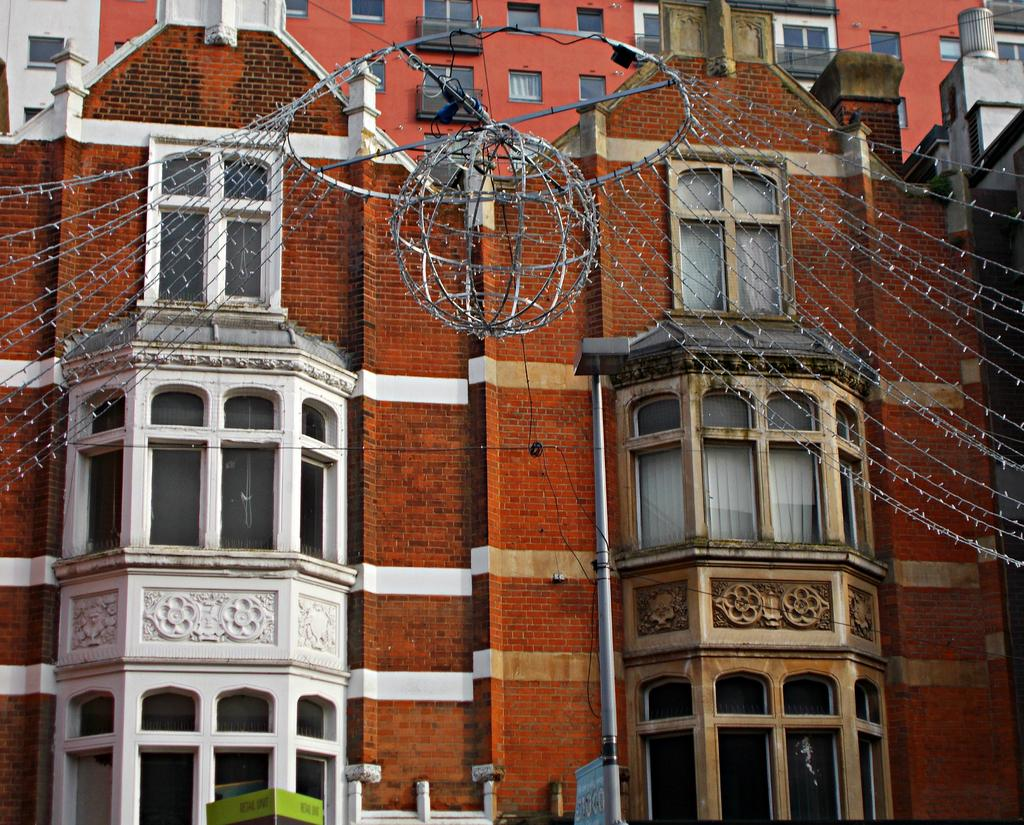What type of structure is visible in the image? There is a building in the image. What is one feature of the building? There is a wall in the image. Are there any openings in the wall? Yes, there are windows in the image. What else can be seen related to lighting in the image? There are wires with lights and a light in the image. Can you describe the signage in the image? There is a board on a pole in the image. What does your dad say about the turkey in the image? There is no turkey present in the image, and the conversation does not involve anyone's dad. How many bulbs are used in the lighting in the image? The image does not specify the number of bulbs used in the lighting, only that there are wires with lights and a light present. 